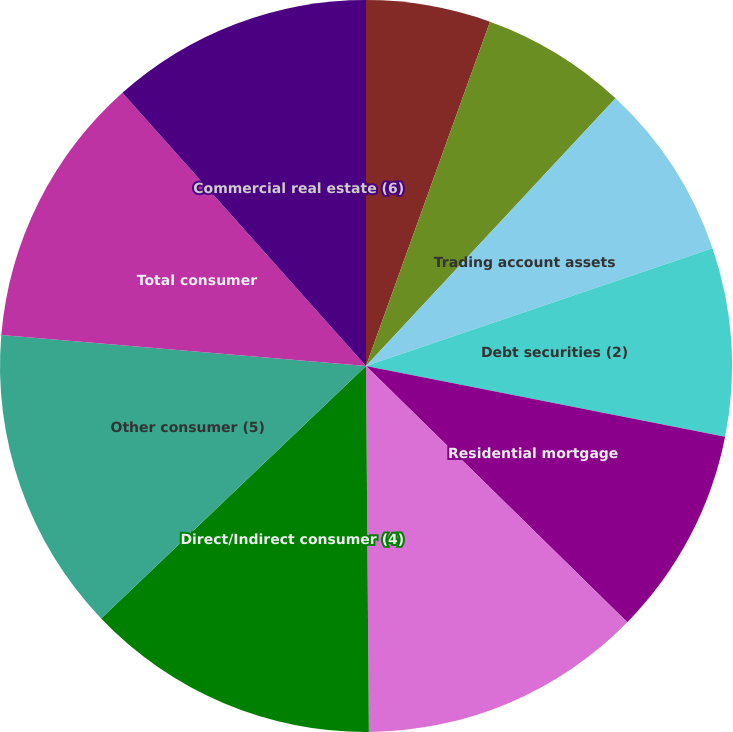Convert chart. <chart><loc_0><loc_0><loc_500><loc_500><pie_chart><fcel>Time deposits placed and other<fcel>Federal funds sold and<fcel>Trading account assets<fcel>Debt securities (2)<fcel>Residential mortgage<fcel>Home equity<fcel>Direct/Indirect consumer (4)<fcel>Other consumer (5)<fcel>Total consumer<fcel>Commercial real estate (6)<nl><fcel>5.5%<fcel>6.44%<fcel>7.84%<fcel>8.31%<fcel>9.25%<fcel>12.53%<fcel>13.0%<fcel>13.47%<fcel>12.06%<fcel>11.59%<nl></chart> 